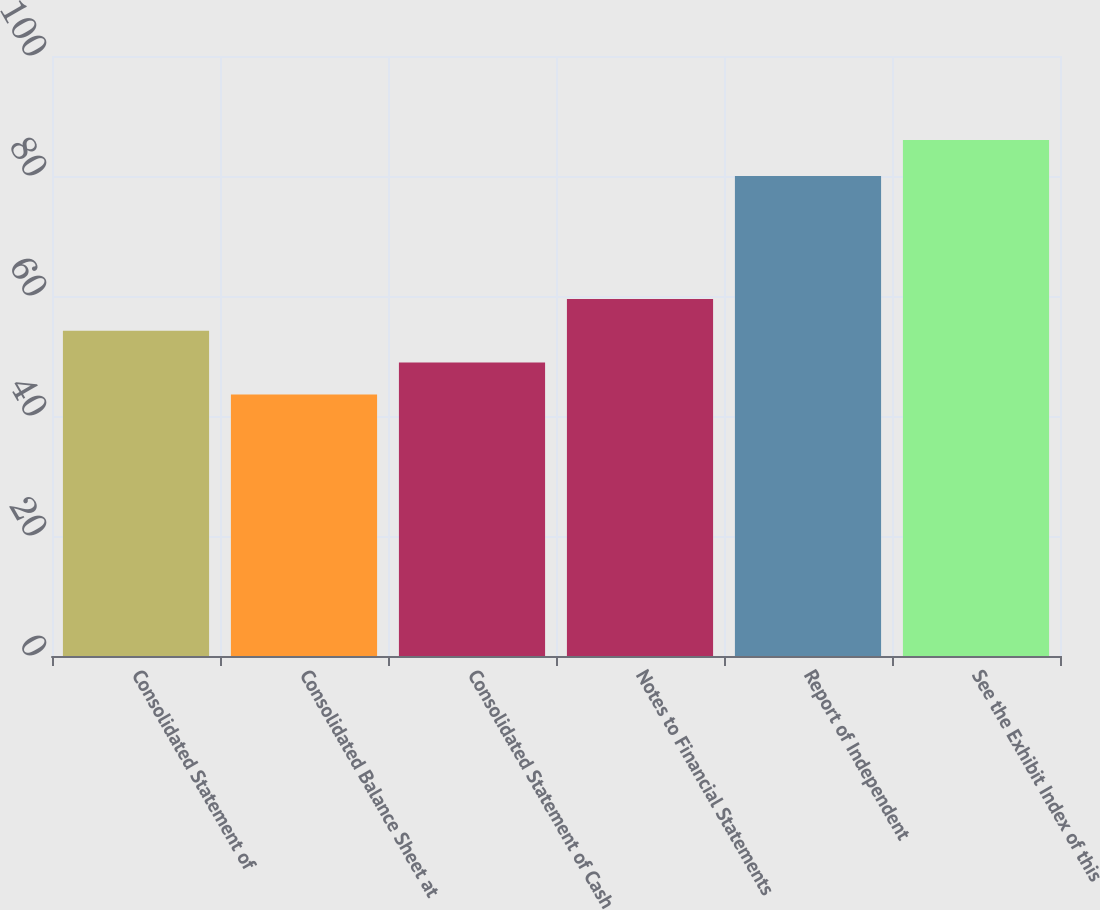Convert chart. <chart><loc_0><loc_0><loc_500><loc_500><bar_chart><fcel>Consolidated Statement of<fcel>Consolidated Balance Sheet at<fcel>Consolidated Statement of Cash<fcel>Notes to Financial Statements<fcel>Report of Independent<fcel>See the Exhibit Index of this<nl><fcel>54.2<fcel>43.6<fcel>48.9<fcel>59.5<fcel>80<fcel>86<nl></chart> 